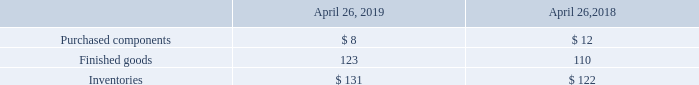6. Supplemental Financial Information
Inventories (in millions):
What was the amount of purchased components in 2019?
Answer scale should be: million. 8. What was the amount of finished goods in 2019?
Answer scale should be: million. 123. What was the amount of inventories in 2018?
Answer scale should be: million. 122. What was the change in purchased components between 2018 and 2019?
Answer scale should be: million. 8-12
Answer: -4. What was the change in finished goods between 2018 and 2019?
Answer scale should be: million. 123-110
Answer: 13. What was the percentage change in inventories between 2018 and 2019?
Answer scale should be: percent. (131-122)/122
Answer: 7.38. 